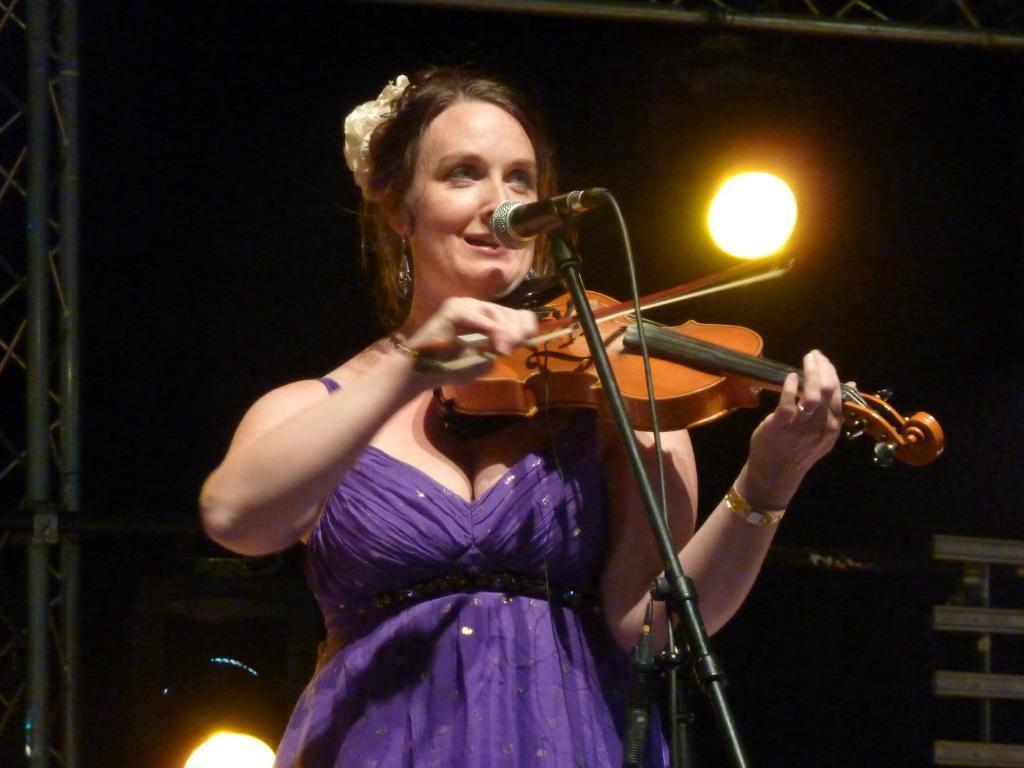Who is the main subject in the image? There is a woman in the image. What is the woman doing in the image? The woman is standing in front of a microphone and playing a guitar. Can you describe the lighting in the image? There is a light visible in the image. What type of finger is the fireman using to play the guitar in the image? There is no fireman present in the image, and the woman is playing the guitar, not a fireman. 